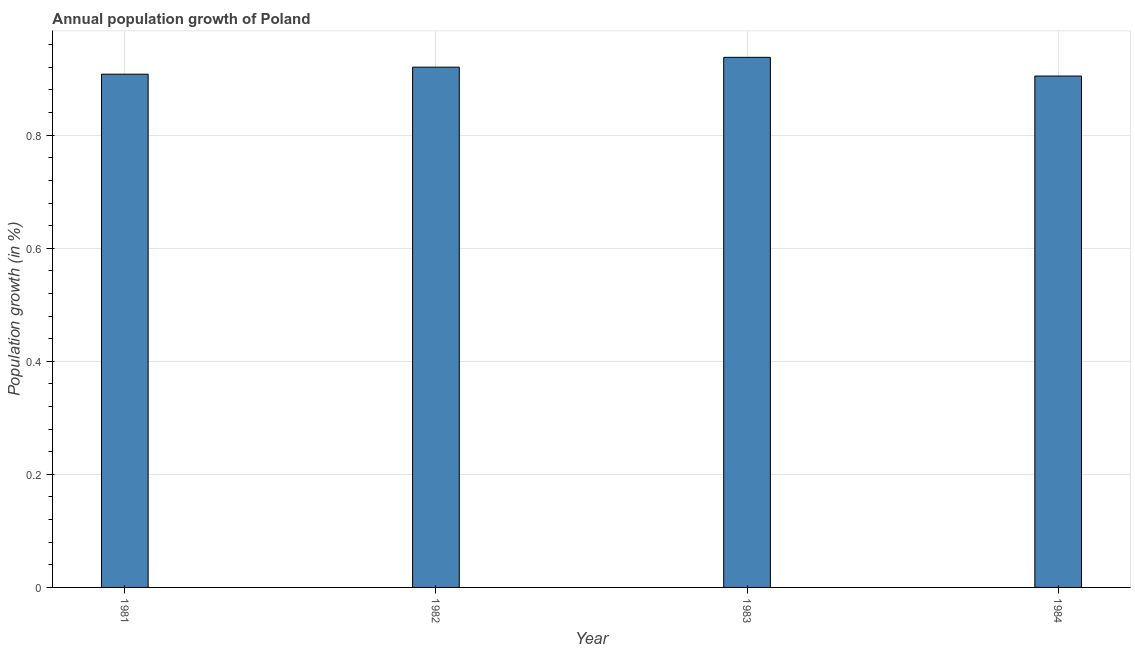What is the title of the graph?
Your response must be concise. Annual population growth of Poland. What is the label or title of the X-axis?
Your response must be concise. Year. What is the label or title of the Y-axis?
Your answer should be very brief. Population growth (in %). What is the population growth in 1982?
Offer a very short reply. 0.92. Across all years, what is the maximum population growth?
Offer a terse response. 0.94. Across all years, what is the minimum population growth?
Your response must be concise. 0.9. In which year was the population growth minimum?
Offer a very short reply. 1984. What is the sum of the population growth?
Keep it short and to the point. 3.67. What is the difference between the population growth in 1982 and 1984?
Provide a succinct answer. 0.02. What is the average population growth per year?
Provide a succinct answer. 0.92. What is the median population growth?
Provide a succinct answer. 0.91. In how many years, is the population growth greater than 0.16 %?
Offer a very short reply. 4. Is the population growth in 1981 less than that in 1984?
Give a very brief answer. No. Is the difference between the population growth in 1981 and 1984 greater than the difference between any two years?
Your answer should be very brief. No. What is the difference between the highest and the second highest population growth?
Provide a succinct answer. 0.02. In how many years, is the population growth greater than the average population growth taken over all years?
Provide a succinct answer. 2. How many bars are there?
Your response must be concise. 4. Are all the bars in the graph horizontal?
Your answer should be very brief. No. How many years are there in the graph?
Your answer should be very brief. 4. What is the difference between two consecutive major ticks on the Y-axis?
Provide a short and direct response. 0.2. What is the Population growth (in %) of 1981?
Your response must be concise. 0.91. What is the Population growth (in %) in 1982?
Give a very brief answer. 0.92. What is the Population growth (in %) in 1983?
Offer a very short reply. 0.94. What is the Population growth (in %) of 1984?
Your response must be concise. 0.9. What is the difference between the Population growth (in %) in 1981 and 1982?
Your response must be concise. -0.01. What is the difference between the Population growth (in %) in 1981 and 1983?
Your answer should be compact. -0.03. What is the difference between the Population growth (in %) in 1981 and 1984?
Keep it short and to the point. 0. What is the difference between the Population growth (in %) in 1982 and 1983?
Offer a very short reply. -0.02. What is the difference between the Population growth (in %) in 1982 and 1984?
Your response must be concise. 0.02. What is the difference between the Population growth (in %) in 1983 and 1984?
Offer a very short reply. 0.03. What is the ratio of the Population growth (in %) in 1981 to that in 1983?
Offer a terse response. 0.97. What is the ratio of the Population growth (in %) in 1981 to that in 1984?
Offer a very short reply. 1. What is the ratio of the Population growth (in %) in 1982 to that in 1983?
Keep it short and to the point. 0.98. 